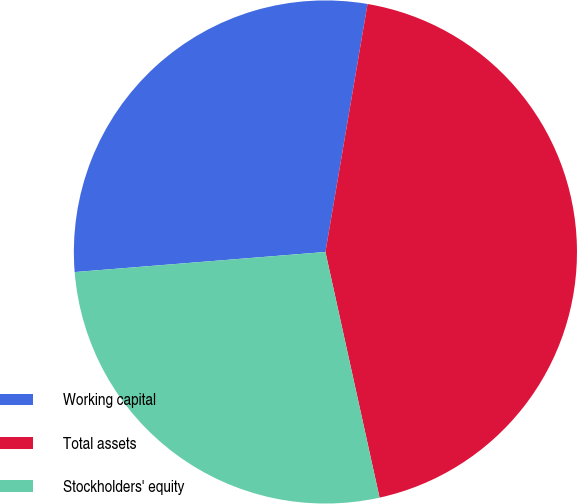<chart> <loc_0><loc_0><loc_500><loc_500><pie_chart><fcel>Working capital<fcel>Total assets<fcel>Stockholders' equity<nl><fcel>28.95%<fcel>43.87%<fcel>27.18%<nl></chart> 